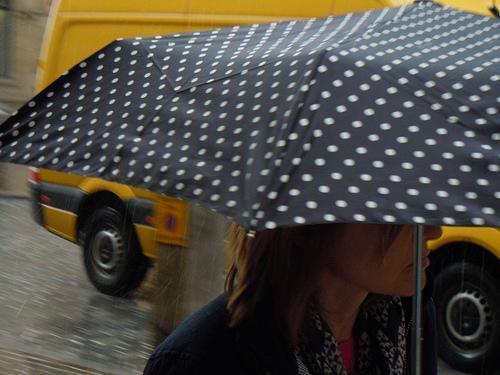How many umbrella?
Give a very brief answer. 1. How many striped umbrellas are there?
Give a very brief answer. 0. 